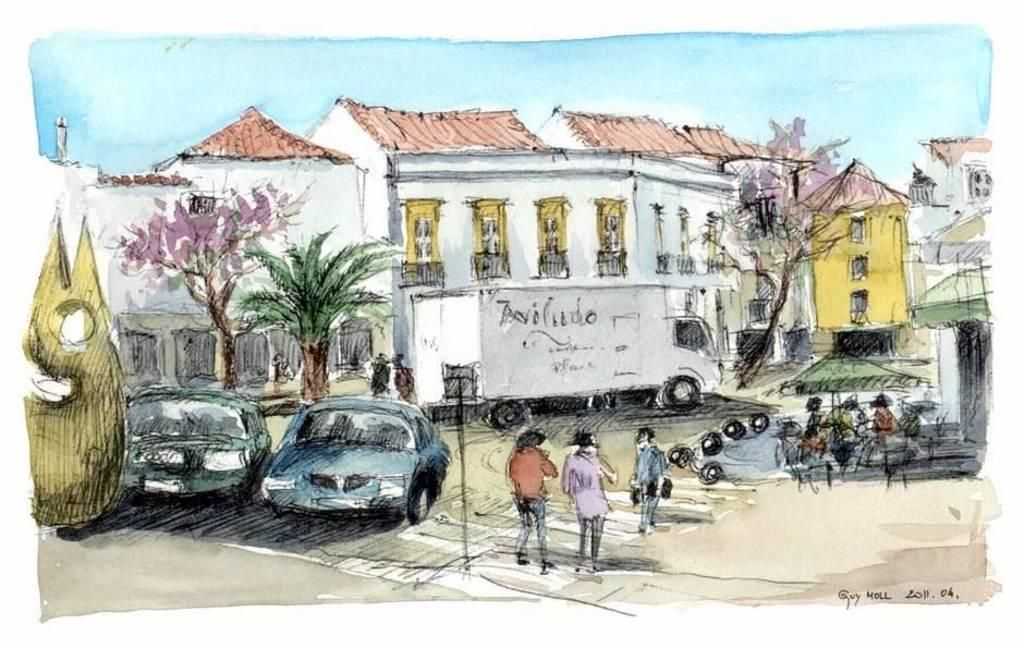Who or what can be seen in the image? There are people in the image. What type of structures are visible in the image? There are buildings in the image. What other natural elements can be seen in the image? There are trees in the image. What architectural features are present in the image? There are windows in the image. What else is present in the image besides people, buildings, and trees? There are vehicles in the image. What is the color of the sky in the image? The sky is blue in color. What type of wax can be seen melting on the windows in the image? There is no wax present in the image; it only features people, buildings, trees, vehicles, and a blue sky. What type of growth can be seen on the buildings in the image? There is no specific growth mentioned or visible in the image; it only features people, buildings, trees, vehicles, and a blue sky. 